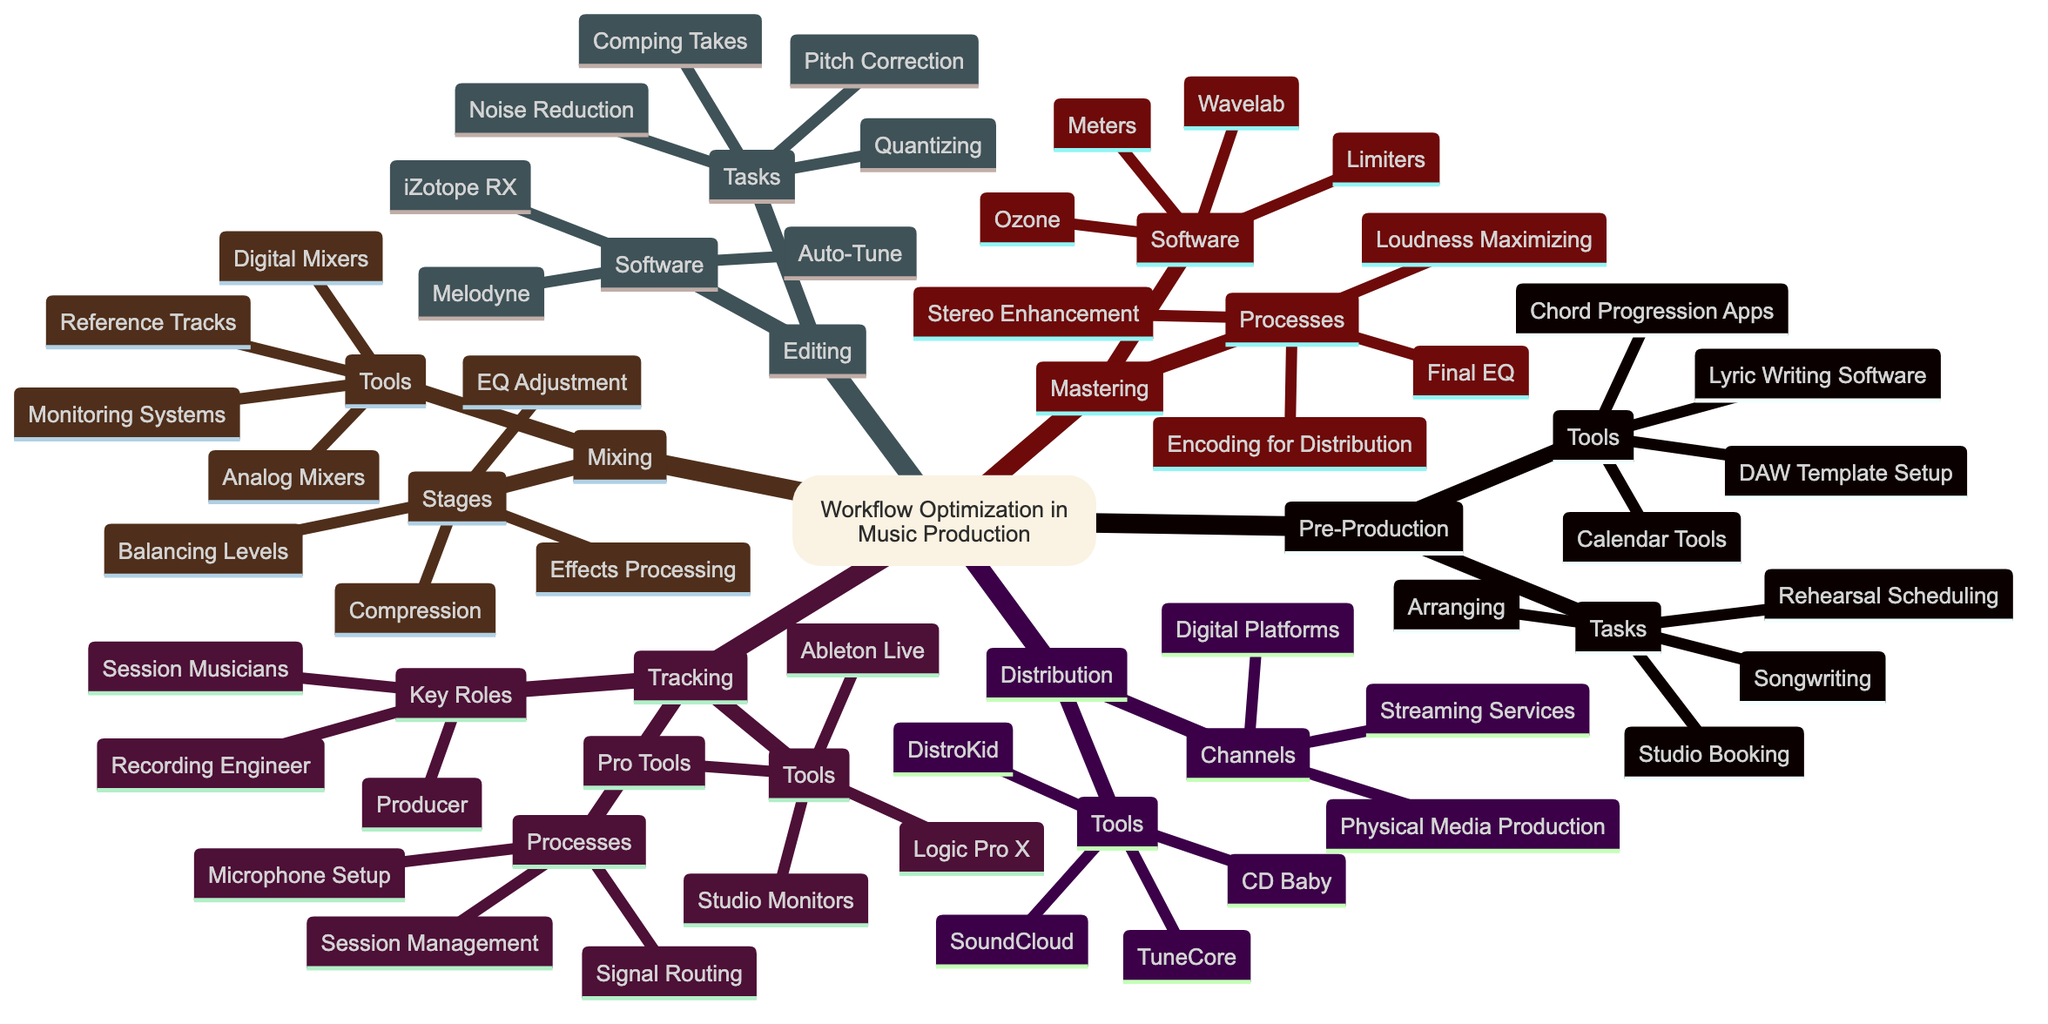What are the tasks involved in Pre-Production? The diagram lists the tasks under Pre-Production, which include Songwriting, Arranging, Rehearsal Scheduling, and Studio Booking.
Answer: Songwriting, Arranging, Rehearsal Scheduling, Studio Booking How many key roles are there in the Tracking phase? In the Tracking section, three key roles are mentioned: Recording Engineer, Session Musicians, and Producer. Therefore, counting them gives us a total of three.
Answer: 3 What is the first task listed in Editing? By looking in the Editing section, the first task listed is Comping Takes.
Answer: Comping Takes What processes are included in the Mastering phase? The diagram outlines four processes involved in Mastering: Final EQ, Stereo Enhancement, Loudness Maximizing, and Encoding for Distribution.
Answer: Final EQ, Stereo Enhancement, Loudness Maximizing, Encoding for Distribution What software is used for Editing tasks? In the Editing section, three software tools are mentioned: Melodyne, Auto-Tune, and iZotope RX.
Answer: Melodyne, Auto-Tune, iZotope RX Which tools are used in the Mixing stage? The Mixing stage lists four tools used: Analog Mixers, Digital Mixers, Monitoring Systems, and Reference Tracks.
Answer: Analog Mixers, Digital Mixers, Monitoring Systems, Reference Tracks How many channels are listed in the Distribution phase? The Distribution section includes three channels: Digital Platforms, Streaming Services, and Physical Media Production, resulting in a total of three channels.
Answer: 3 What is a key role associated with Tracking? Within the Tracking section, one key role mentioned is the Producer, which is representative of the roles involved in this phase of music production.
Answer: Producer What is the purpose of using DAW Template Setup in Pre-Production? In Pre-Production, DAW Template Setup is used to streamline the setup process for recording, ensuring that all necessary elements are prepared in advance for efficient workflow.
Answer: Streamline the setup process What are the stages involved in Mixing? The Mixing phase consists of four stages: Balancing Levels, EQ Adjustment, Compression, and Effects Processing. This shows the sequential steps taken in the Mixing process.
Answer: Balancing Levels, EQ Adjustment, Compression, Effects Processing 